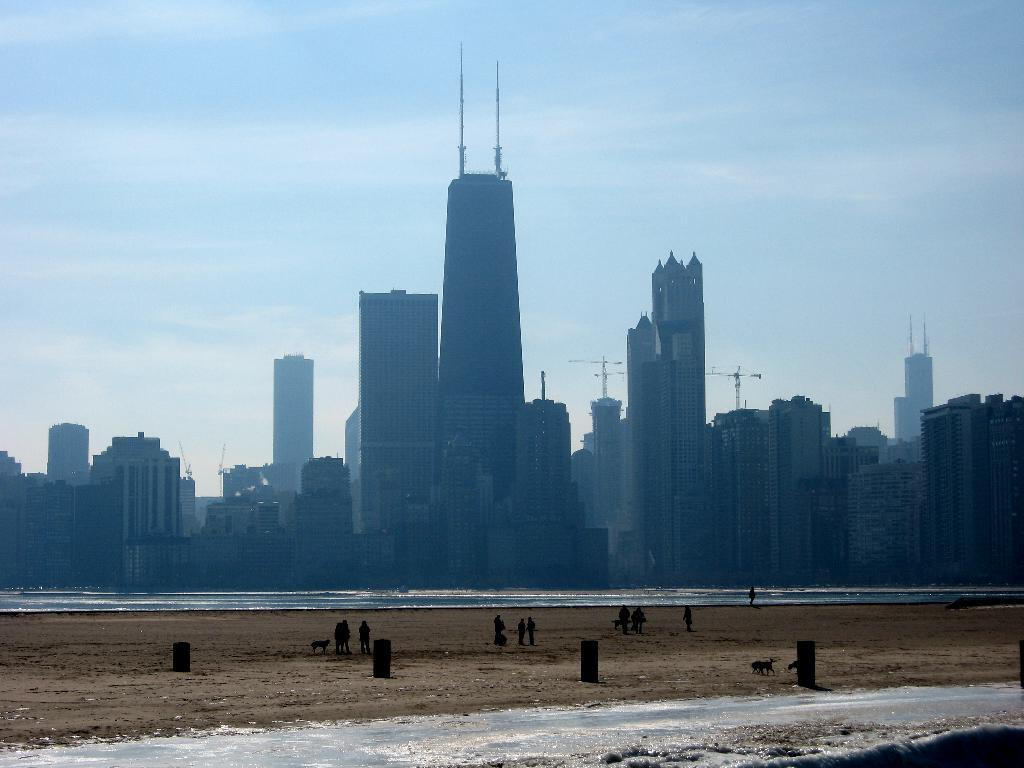Who or what can be seen in the image? There are people and animals in the image. What can be seen in the background of the image? There are buildings in the background of the image. What natural elements are visible in the image? There is water and sand visible in the image. What type of afterthought is being expressed by the animals in the image? There is no indication of any afterthought being expressed by the animals in the image. How many quarters are visible in the image? There is no mention of quarters in the image, so it cannot be determined how many are visible. 